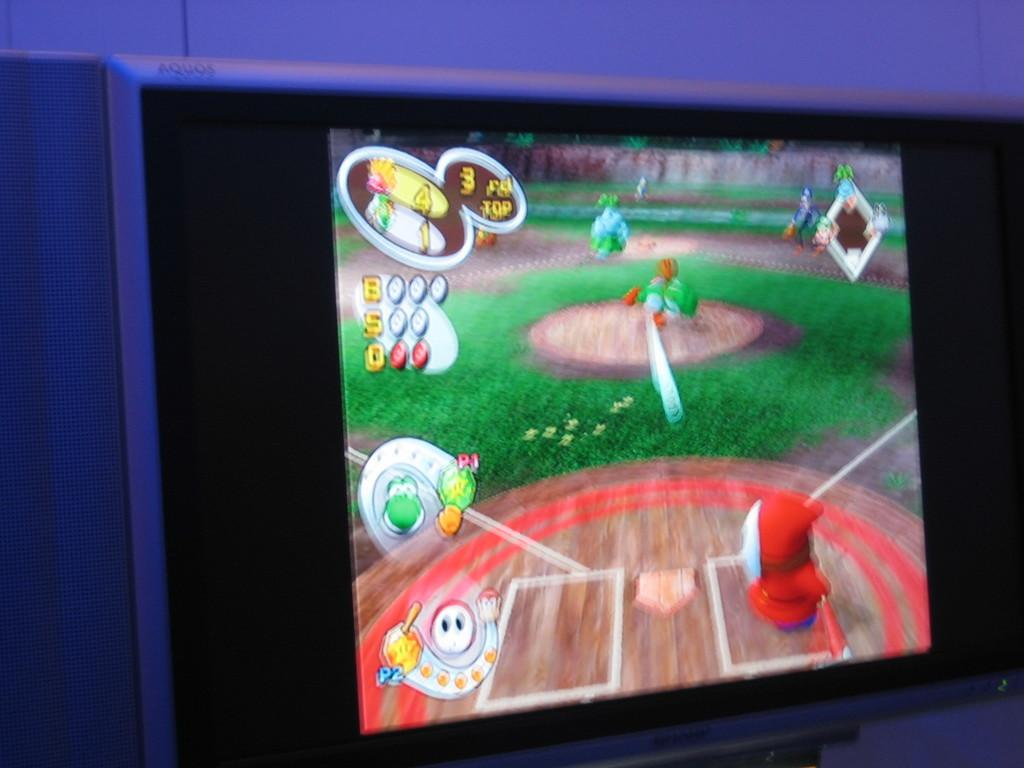<image>
Offer a succinct explanation of the picture presented. Nintendo baseball game of where shy guy is the batter ready to hit the ball and the score is 4 to 1. 